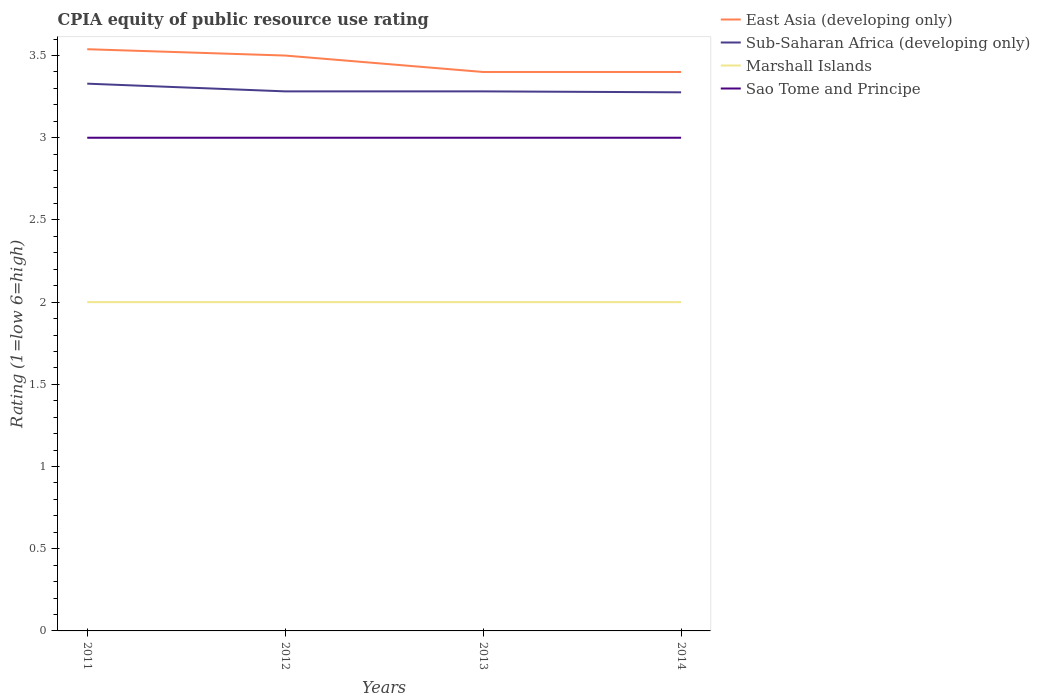Is the number of lines equal to the number of legend labels?
Offer a very short reply. Yes. In which year was the CPIA rating in Sub-Saharan Africa (developing only) maximum?
Offer a terse response. 2014. What is the total CPIA rating in East Asia (developing only) in the graph?
Make the answer very short. 0.1. What is the difference between the highest and the second highest CPIA rating in Sao Tome and Principe?
Your answer should be very brief. 0. How many legend labels are there?
Your answer should be very brief. 4. How are the legend labels stacked?
Your response must be concise. Vertical. What is the title of the graph?
Offer a terse response. CPIA equity of public resource use rating. Does "Kuwait" appear as one of the legend labels in the graph?
Offer a terse response. No. What is the label or title of the X-axis?
Provide a short and direct response. Years. What is the label or title of the Y-axis?
Provide a short and direct response. Rating (1=low 6=high). What is the Rating (1=low 6=high) in East Asia (developing only) in 2011?
Your answer should be very brief. 3.54. What is the Rating (1=low 6=high) in Sub-Saharan Africa (developing only) in 2011?
Provide a succinct answer. 3.33. What is the Rating (1=low 6=high) in Sub-Saharan Africa (developing only) in 2012?
Your answer should be very brief. 3.28. What is the Rating (1=low 6=high) in Marshall Islands in 2012?
Give a very brief answer. 2. What is the Rating (1=low 6=high) of East Asia (developing only) in 2013?
Your answer should be compact. 3.4. What is the Rating (1=low 6=high) in Sub-Saharan Africa (developing only) in 2013?
Make the answer very short. 3.28. What is the Rating (1=low 6=high) of Sao Tome and Principe in 2013?
Provide a short and direct response. 3. What is the Rating (1=low 6=high) in Sub-Saharan Africa (developing only) in 2014?
Give a very brief answer. 3.28. Across all years, what is the maximum Rating (1=low 6=high) in East Asia (developing only)?
Your response must be concise. 3.54. Across all years, what is the maximum Rating (1=low 6=high) of Sub-Saharan Africa (developing only)?
Offer a very short reply. 3.33. Across all years, what is the maximum Rating (1=low 6=high) of Sao Tome and Principe?
Keep it short and to the point. 3. Across all years, what is the minimum Rating (1=low 6=high) of East Asia (developing only)?
Keep it short and to the point. 3.4. Across all years, what is the minimum Rating (1=low 6=high) of Sub-Saharan Africa (developing only)?
Your answer should be compact. 3.28. Across all years, what is the minimum Rating (1=low 6=high) in Sao Tome and Principe?
Your response must be concise. 3. What is the total Rating (1=low 6=high) in East Asia (developing only) in the graph?
Offer a very short reply. 13.84. What is the total Rating (1=low 6=high) in Sub-Saharan Africa (developing only) in the graph?
Offer a terse response. 13.17. What is the difference between the Rating (1=low 6=high) in East Asia (developing only) in 2011 and that in 2012?
Your answer should be compact. 0.04. What is the difference between the Rating (1=low 6=high) of Sub-Saharan Africa (developing only) in 2011 and that in 2012?
Your answer should be very brief. 0.05. What is the difference between the Rating (1=low 6=high) of Sao Tome and Principe in 2011 and that in 2012?
Your response must be concise. 0. What is the difference between the Rating (1=low 6=high) of East Asia (developing only) in 2011 and that in 2013?
Your response must be concise. 0.14. What is the difference between the Rating (1=low 6=high) of Sub-Saharan Africa (developing only) in 2011 and that in 2013?
Offer a very short reply. 0.05. What is the difference between the Rating (1=low 6=high) of Marshall Islands in 2011 and that in 2013?
Keep it short and to the point. 0. What is the difference between the Rating (1=low 6=high) of East Asia (developing only) in 2011 and that in 2014?
Your answer should be compact. 0.14. What is the difference between the Rating (1=low 6=high) in Sub-Saharan Africa (developing only) in 2011 and that in 2014?
Your answer should be compact. 0.05. What is the difference between the Rating (1=low 6=high) of Marshall Islands in 2011 and that in 2014?
Make the answer very short. 0. What is the difference between the Rating (1=low 6=high) of Sao Tome and Principe in 2011 and that in 2014?
Make the answer very short. 0. What is the difference between the Rating (1=low 6=high) of East Asia (developing only) in 2012 and that in 2013?
Offer a terse response. 0.1. What is the difference between the Rating (1=low 6=high) of Sub-Saharan Africa (developing only) in 2012 and that in 2013?
Give a very brief answer. 0. What is the difference between the Rating (1=low 6=high) in Marshall Islands in 2012 and that in 2013?
Keep it short and to the point. 0. What is the difference between the Rating (1=low 6=high) in Sao Tome and Principe in 2012 and that in 2013?
Provide a succinct answer. 0. What is the difference between the Rating (1=low 6=high) of Sub-Saharan Africa (developing only) in 2012 and that in 2014?
Your answer should be compact. 0.01. What is the difference between the Rating (1=low 6=high) in Marshall Islands in 2012 and that in 2014?
Offer a very short reply. 0. What is the difference between the Rating (1=low 6=high) of Sub-Saharan Africa (developing only) in 2013 and that in 2014?
Give a very brief answer. 0.01. What is the difference between the Rating (1=low 6=high) of Sao Tome and Principe in 2013 and that in 2014?
Offer a terse response. 0. What is the difference between the Rating (1=low 6=high) of East Asia (developing only) in 2011 and the Rating (1=low 6=high) of Sub-Saharan Africa (developing only) in 2012?
Offer a terse response. 0.26. What is the difference between the Rating (1=low 6=high) of East Asia (developing only) in 2011 and the Rating (1=low 6=high) of Marshall Islands in 2012?
Make the answer very short. 1.54. What is the difference between the Rating (1=low 6=high) of East Asia (developing only) in 2011 and the Rating (1=low 6=high) of Sao Tome and Principe in 2012?
Your answer should be very brief. 0.54. What is the difference between the Rating (1=low 6=high) in Sub-Saharan Africa (developing only) in 2011 and the Rating (1=low 6=high) in Marshall Islands in 2012?
Provide a succinct answer. 1.33. What is the difference between the Rating (1=low 6=high) in Sub-Saharan Africa (developing only) in 2011 and the Rating (1=low 6=high) in Sao Tome and Principe in 2012?
Your response must be concise. 0.33. What is the difference between the Rating (1=low 6=high) in East Asia (developing only) in 2011 and the Rating (1=low 6=high) in Sub-Saharan Africa (developing only) in 2013?
Your answer should be compact. 0.26. What is the difference between the Rating (1=low 6=high) in East Asia (developing only) in 2011 and the Rating (1=low 6=high) in Marshall Islands in 2013?
Offer a terse response. 1.54. What is the difference between the Rating (1=low 6=high) in East Asia (developing only) in 2011 and the Rating (1=low 6=high) in Sao Tome and Principe in 2013?
Your answer should be very brief. 0.54. What is the difference between the Rating (1=low 6=high) in Sub-Saharan Africa (developing only) in 2011 and the Rating (1=low 6=high) in Marshall Islands in 2013?
Give a very brief answer. 1.33. What is the difference between the Rating (1=low 6=high) of Sub-Saharan Africa (developing only) in 2011 and the Rating (1=low 6=high) of Sao Tome and Principe in 2013?
Your answer should be compact. 0.33. What is the difference between the Rating (1=low 6=high) in Marshall Islands in 2011 and the Rating (1=low 6=high) in Sao Tome and Principe in 2013?
Give a very brief answer. -1. What is the difference between the Rating (1=low 6=high) in East Asia (developing only) in 2011 and the Rating (1=low 6=high) in Sub-Saharan Africa (developing only) in 2014?
Give a very brief answer. 0.26. What is the difference between the Rating (1=low 6=high) in East Asia (developing only) in 2011 and the Rating (1=low 6=high) in Marshall Islands in 2014?
Your answer should be compact. 1.54. What is the difference between the Rating (1=low 6=high) in East Asia (developing only) in 2011 and the Rating (1=low 6=high) in Sao Tome and Principe in 2014?
Your response must be concise. 0.54. What is the difference between the Rating (1=low 6=high) in Sub-Saharan Africa (developing only) in 2011 and the Rating (1=low 6=high) in Marshall Islands in 2014?
Keep it short and to the point. 1.33. What is the difference between the Rating (1=low 6=high) in Sub-Saharan Africa (developing only) in 2011 and the Rating (1=low 6=high) in Sao Tome and Principe in 2014?
Provide a succinct answer. 0.33. What is the difference between the Rating (1=low 6=high) in East Asia (developing only) in 2012 and the Rating (1=low 6=high) in Sub-Saharan Africa (developing only) in 2013?
Your response must be concise. 0.22. What is the difference between the Rating (1=low 6=high) in East Asia (developing only) in 2012 and the Rating (1=low 6=high) in Marshall Islands in 2013?
Ensure brevity in your answer.  1.5. What is the difference between the Rating (1=low 6=high) of East Asia (developing only) in 2012 and the Rating (1=low 6=high) of Sao Tome and Principe in 2013?
Provide a short and direct response. 0.5. What is the difference between the Rating (1=low 6=high) of Sub-Saharan Africa (developing only) in 2012 and the Rating (1=low 6=high) of Marshall Islands in 2013?
Your answer should be compact. 1.28. What is the difference between the Rating (1=low 6=high) in Sub-Saharan Africa (developing only) in 2012 and the Rating (1=low 6=high) in Sao Tome and Principe in 2013?
Provide a short and direct response. 0.28. What is the difference between the Rating (1=low 6=high) in East Asia (developing only) in 2012 and the Rating (1=low 6=high) in Sub-Saharan Africa (developing only) in 2014?
Your answer should be compact. 0.22. What is the difference between the Rating (1=low 6=high) of East Asia (developing only) in 2012 and the Rating (1=low 6=high) of Sao Tome and Principe in 2014?
Offer a very short reply. 0.5. What is the difference between the Rating (1=low 6=high) in Sub-Saharan Africa (developing only) in 2012 and the Rating (1=low 6=high) in Marshall Islands in 2014?
Make the answer very short. 1.28. What is the difference between the Rating (1=low 6=high) of Sub-Saharan Africa (developing only) in 2012 and the Rating (1=low 6=high) of Sao Tome and Principe in 2014?
Ensure brevity in your answer.  0.28. What is the difference between the Rating (1=low 6=high) in Marshall Islands in 2012 and the Rating (1=low 6=high) in Sao Tome and Principe in 2014?
Ensure brevity in your answer.  -1. What is the difference between the Rating (1=low 6=high) in East Asia (developing only) in 2013 and the Rating (1=low 6=high) in Sub-Saharan Africa (developing only) in 2014?
Offer a terse response. 0.12. What is the difference between the Rating (1=low 6=high) in East Asia (developing only) in 2013 and the Rating (1=low 6=high) in Marshall Islands in 2014?
Make the answer very short. 1.4. What is the difference between the Rating (1=low 6=high) of Sub-Saharan Africa (developing only) in 2013 and the Rating (1=low 6=high) of Marshall Islands in 2014?
Your answer should be very brief. 1.28. What is the difference between the Rating (1=low 6=high) of Sub-Saharan Africa (developing only) in 2013 and the Rating (1=low 6=high) of Sao Tome and Principe in 2014?
Your response must be concise. 0.28. What is the difference between the Rating (1=low 6=high) of Marshall Islands in 2013 and the Rating (1=low 6=high) of Sao Tome and Principe in 2014?
Make the answer very short. -1. What is the average Rating (1=low 6=high) in East Asia (developing only) per year?
Make the answer very short. 3.46. What is the average Rating (1=low 6=high) of Sub-Saharan Africa (developing only) per year?
Your answer should be compact. 3.29. In the year 2011, what is the difference between the Rating (1=low 6=high) in East Asia (developing only) and Rating (1=low 6=high) in Sub-Saharan Africa (developing only)?
Offer a terse response. 0.21. In the year 2011, what is the difference between the Rating (1=low 6=high) in East Asia (developing only) and Rating (1=low 6=high) in Marshall Islands?
Provide a succinct answer. 1.54. In the year 2011, what is the difference between the Rating (1=low 6=high) of East Asia (developing only) and Rating (1=low 6=high) of Sao Tome and Principe?
Ensure brevity in your answer.  0.54. In the year 2011, what is the difference between the Rating (1=low 6=high) of Sub-Saharan Africa (developing only) and Rating (1=low 6=high) of Marshall Islands?
Provide a short and direct response. 1.33. In the year 2011, what is the difference between the Rating (1=low 6=high) of Sub-Saharan Africa (developing only) and Rating (1=low 6=high) of Sao Tome and Principe?
Provide a short and direct response. 0.33. In the year 2011, what is the difference between the Rating (1=low 6=high) in Marshall Islands and Rating (1=low 6=high) in Sao Tome and Principe?
Your response must be concise. -1. In the year 2012, what is the difference between the Rating (1=low 6=high) of East Asia (developing only) and Rating (1=low 6=high) of Sub-Saharan Africa (developing only)?
Provide a succinct answer. 0.22. In the year 2012, what is the difference between the Rating (1=low 6=high) in East Asia (developing only) and Rating (1=low 6=high) in Marshall Islands?
Your answer should be compact. 1.5. In the year 2012, what is the difference between the Rating (1=low 6=high) of Sub-Saharan Africa (developing only) and Rating (1=low 6=high) of Marshall Islands?
Your answer should be very brief. 1.28. In the year 2012, what is the difference between the Rating (1=low 6=high) in Sub-Saharan Africa (developing only) and Rating (1=low 6=high) in Sao Tome and Principe?
Make the answer very short. 0.28. In the year 2013, what is the difference between the Rating (1=low 6=high) in East Asia (developing only) and Rating (1=low 6=high) in Sub-Saharan Africa (developing only)?
Keep it short and to the point. 0.12. In the year 2013, what is the difference between the Rating (1=low 6=high) in East Asia (developing only) and Rating (1=low 6=high) in Marshall Islands?
Provide a succinct answer. 1.4. In the year 2013, what is the difference between the Rating (1=low 6=high) of East Asia (developing only) and Rating (1=low 6=high) of Sao Tome and Principe?
Offer a terse response. 0.4. In the year 2013, what is the difference between the Rating (1=low 6=high) of Sub-Saharan Africa (developing only) and Rating (1=low 6=high) of Marshall Islands?
Provide a short and direct response. 1.28. In the year 2013, what is the difference between the Rating (1=low 6=high) of Sub-Saharan Africa (developing only) and Rating (1=low 6=high) of Sao Tome and Principe?
Offer a terse response. 0.28. In the year 2014, what is the difference between the Rating (1=low 6=high) of East Asia (developing only) and Rating (1=low 6=high) of Sub-Saharan Africa (developing only)?
Your answer should be compact. 0.12. In the year 2014, what is the difference between the Rating (1=low 6=high) of East Asia (developing only) and Rating (1=low 6=high) of Sao Tome and Principe?
Your answer should be very brief. 0.4. In the year 2014, what is the difference between the Rating (1=low 6=high) of Sub-Saharan Africa (developing only) and Rating (1=low 6=high) of Marshall Islands?
Offer a very short reply. 1.28. In the year 2014, what is the difference between the Rating (1=low 6=high) in Sub-Saharan Africa (developing only) and Rating (1=low 6=high) in Sao Tome and Principe?
Keep it short and to the point. 0.28. What is the ratio of the Rating (1=low 6=high) of Sub-Saharan Africa (developing only) in 2011 to that in 2012?
Provide a short and direct response. 1.01. What is the ratio of the Rating (1=low 6=high) of Marshall Islands in 2011 to that in 2012?
Your response must be concise. 1. What is the ratio of the Rating (1=low 6=high) in East Asia (developing only) in 2011 to that in 2013?
Ensure brevity in your answer.  1.04. What is the ratio of the Rating (1=low 6=high) of Sub-Saharan Africa (developing only) in 2011 to that in 2013?
Your answer should be compact. 1.01. What is the ratio of the Rating (1=low 6=high) of Marshall Islands in 2011 to that in 2013?
Offer a very short reply. 1. What is the ratio of the Rating (1=low 6=high) in East Asia (developing only) in 2011 to that in 2014?
Provide a succinct answer. 1.04. What is the ratio of the Rating (1=low 6=high) of Sub-Saharan Africa (developing only) in 2011 to that in 2014?
Your answer should be compact. 1.02. What is the ratio of the Rating (1=low 6=high) of East Asia (developing only) in 2012 to that in 2013?
Offer a very short reply. 1.03. What is the ratio of the Rating (1=low 6=high) of Sao Tome and Principe in 2012 to that in 2013?
Your response must be concise. 1. What is the ratio of the Rating (1=low 6=high) of East Asia (developing only) in 2012 to that in 2014?
Give a very brief answer. 1.03. What is the ratio of the Rating (1=low 6=high) in Sub-Saharan Africa (developing only) in 2012 to that in 2014?
Keep it short and to the point. 1. What is the ratio of the Rating (1=low 6=high) of Sao Tome and Principe in 2012 to that in 2014?
Your answer should be very brief. 1. What is the ratio of the Rating (1=low 6=high) of East Asia (developing only) in 2013 to that in 2014?
Give a very brief answer. 1. What is the ratio of the Rating (1=low 6=high) of Sao Tome and Principe in 2013 to that in 2014?
Give a very brief answer. 1. What is the difference between the highest and the second highest Rating (1=low 6=high) in East Asia (developing only)?
Offer a very short reply. 0.04. What is the difference between the highest and the second highest Rating (1=low 6=high) of Sub-Saharan Africa (developing only)?
Make the answer very short. 0.05. What is the difference between the highest and the second highest Rating (1=low 6=high) in Marshall Islands?
Your answer should be compact. 0. What is the difference between the highest and the lowest Rating (1=low 6=high) in East Asia (developing only)?
Your answer should be compact. 0.14. What is the difference between the highest and the lowest Rating (1=low 6=high) in Sub-Saharan Africa (developing only)?
Provide a short and direct response. 0.05. 